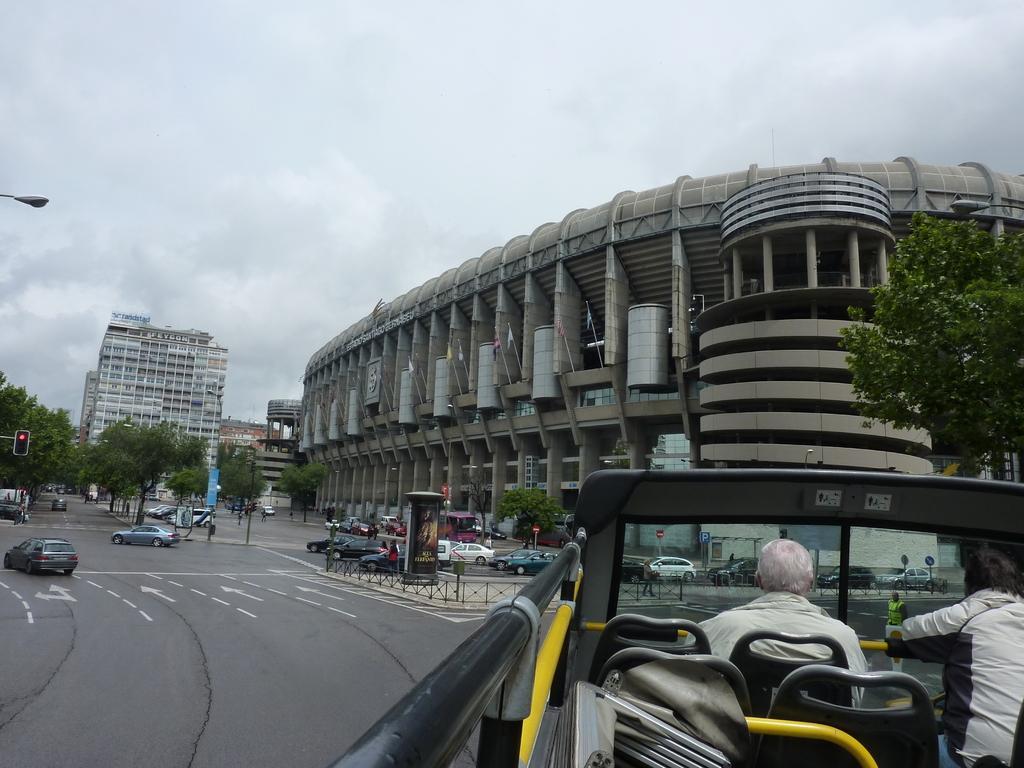In one or two sentences, can you explain what this image depicts? In the image we can see buildings, trees, vehicles on the road, road, fence, light, signal pole, flags and a cloudy sky. We can see there are even people in the vehicle, these are the seats and there are white lines on the road. 